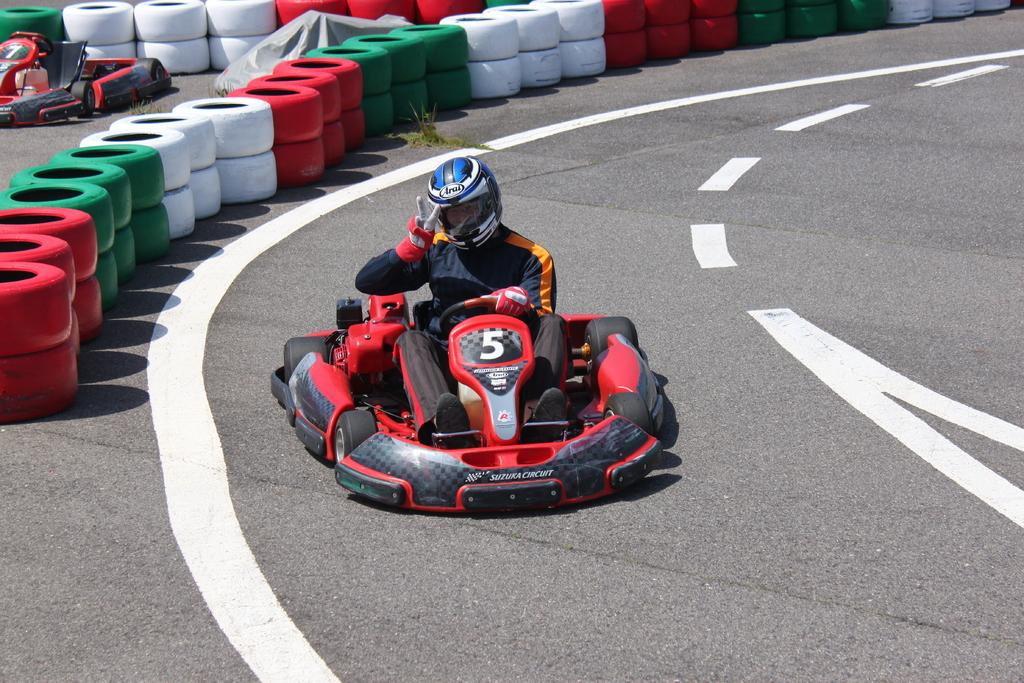What is the main subject in the foreground of the image? There is a man on a go kart in the foreground of the image. Where is the go kart located? The go kart is on the road. What can be seen in the background of the image? There are painted tires, another go kart, and a cover in the background of the image. What type of nut is being used to secure the go kart in the image? There is no nut visible in the image; the go kart is on the road and not being secured. Is there a lock on the cover in the background of the image? There is no lock visible on the cover in the background of the image. 